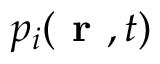Convert formula to latex. <formula><loc_0><loc_0><loc_500><loc_500>p _ { i } ( r , t )</formula> 